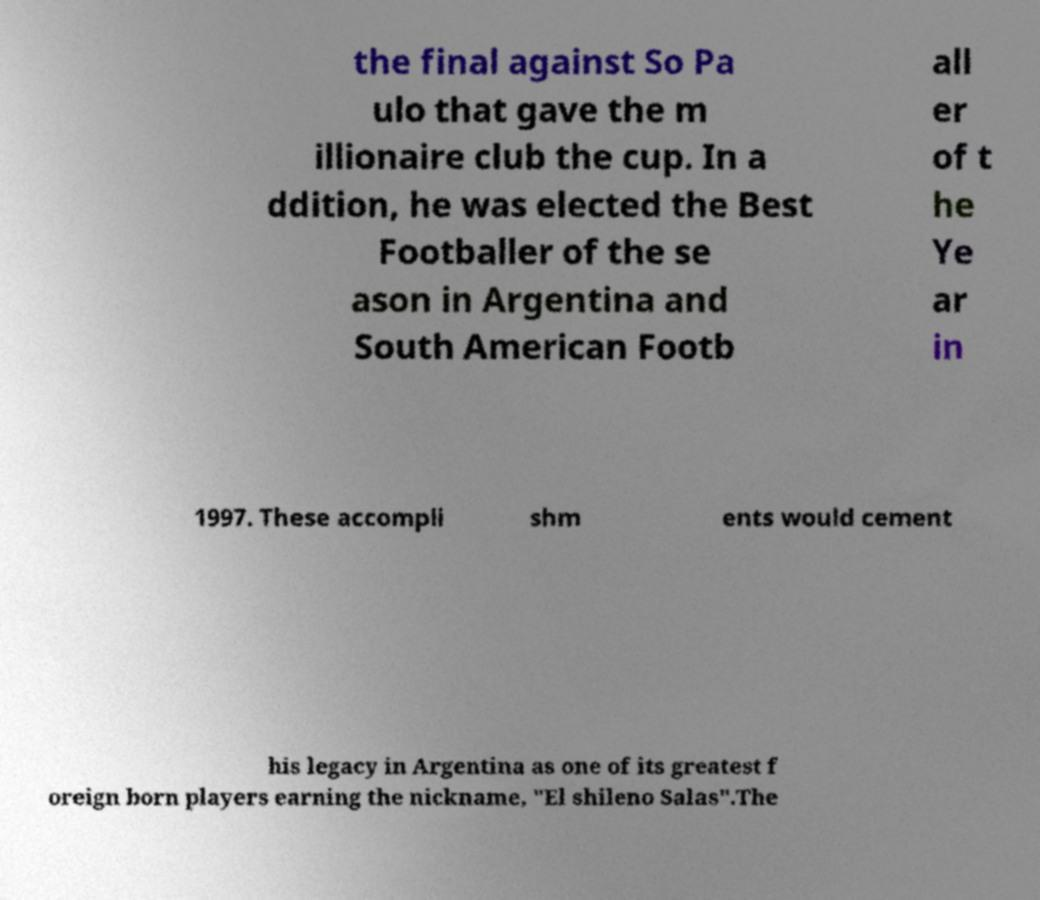What messages or text are displayed in this image? I need them in a readable, typed format. the final against So Pa ulo that gave the m illionaire club the cup. In a ddition, he was elected the Best Footballer of the se ason in Argentina and South American Footb all er of t he Ye ar in 1997. These accompli shm ents would cement his legacy in Argentina as one of its greatest f oreign born players earning the nickname, "El shileno Salas".The 